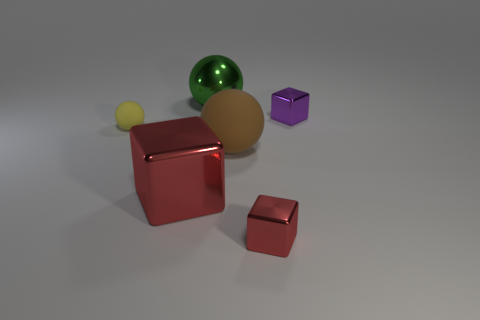What number of objects are either yellow rubber spheres behind the big brown rubber sphere or big green shiny things?
Your answer should be compact. 2. What number of things are large gray metallic objects or red blocks to the right of the big metal block?
Offer a very short reply. 1. How many things are in front of the tiny metallic thing that is to the right of the tiny thing in front of the yellow object?
Your answer should be compact. 4. There is a red object that is the same size as the yellow ball; what material is it?
Make the answer very short. Metal. Is there a green metallic thing that has the same size as the green sphere?
Offer a terse response. No. What color is the tiny ball?
Your answer should be very brief. Yellow. There is a matte object right of the big metal object in front of the tiny yellow rubber object; what color is it?
Offer a terse response. Brown. There is a red metallic object behind the red metal cube on the right side of the red object that is behind the tiny red metallic block; what shape is it?
Offer a very short reply. Cube. How many brown spheres have the same material as the yellow ball?
Offer a terse response. 1. How many red things are right of the big object that is behind the yellow matte thing?
Your response must be concise. 1. 